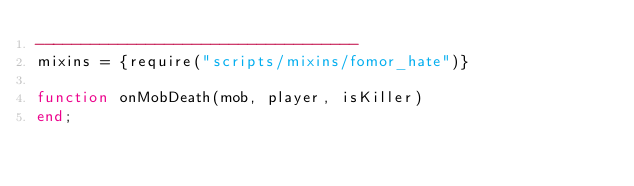<code> <loc_0><loc_0><loc_500><loc_500><_Lua_>-----------------------------------
mixins = {require("scripts/mixins/fomor_hate")}

function onMobDeath(mob, player, isKiller)
end;
</code> 